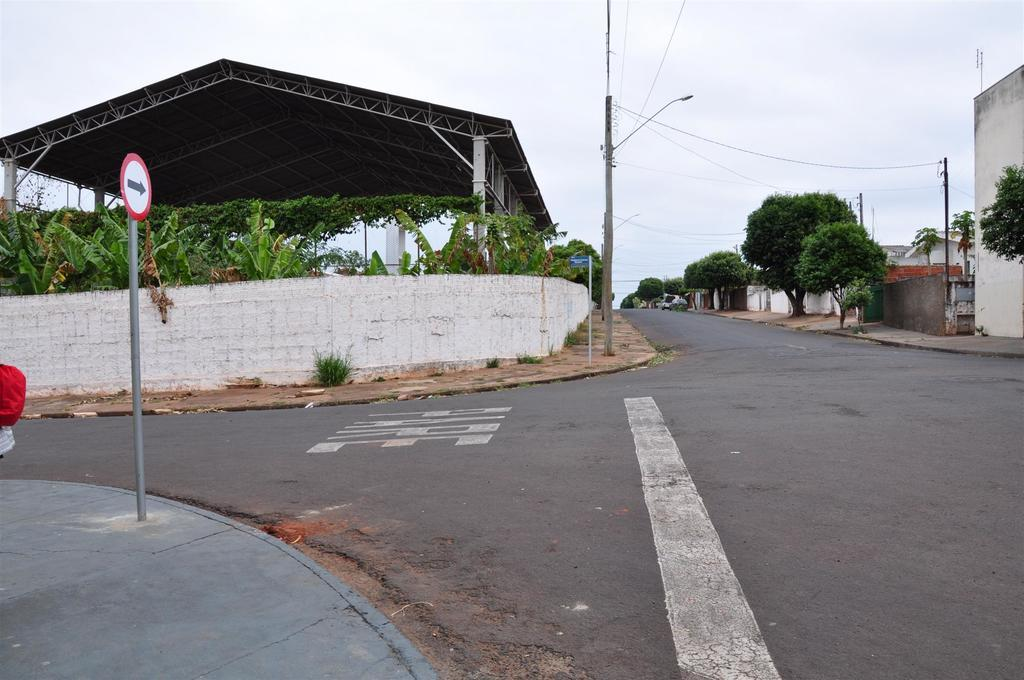What is the main feature of the image? There is a road in the image. What structures can be seen alongside the road? There are light poles in the image. What type of vegetation is present in the image? There are trees with green color in the image. What type of buildings can be seen in the image? There are houses in the image. What additional structure can be found in the image? There is a shed in the image. What is the color of the sky in the image? The sky is white in color. What type of skin condition can be seen on the trees in the image? There is no mention of any skin condition on the trees in the image. The trees are described as having green color, which is a normal characteristic of healthy trees. 